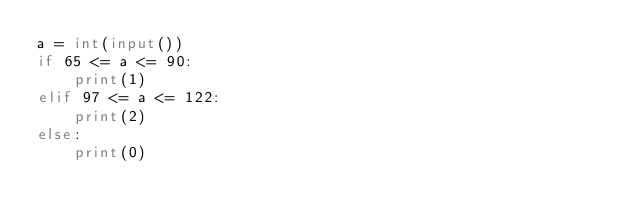<code> <loc_0><loc_0><loc_500><loc_500><_Python_>a = int(input())
if 65 <= a <= 90:
    print(1)
elif 97 <= a <= 122:
    print(2)
else:
    print(0)
</code> 